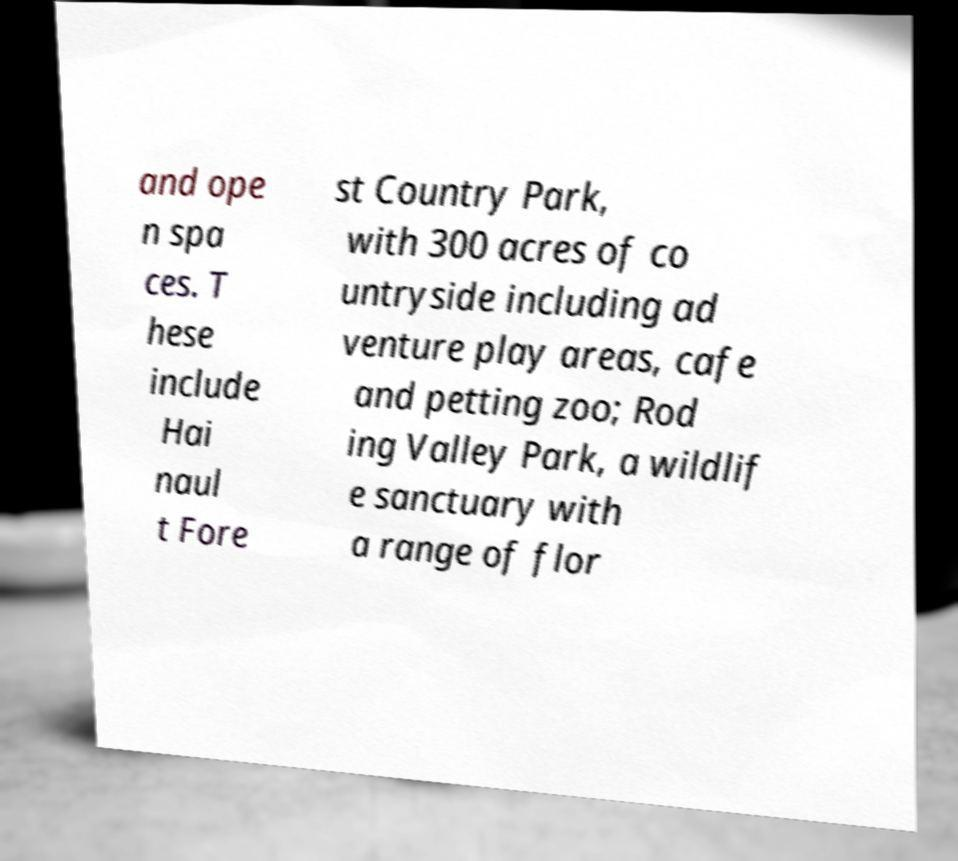Could you extract and type out the text from this image? and ope n spa ces. T hese include Hai naul t Fore st Country Park, with 300 acres of co untryside including ad venture play areas, cafe and petting zoo; Rod ing Valley Park, a wildlif e sanctuary with a range of flor 